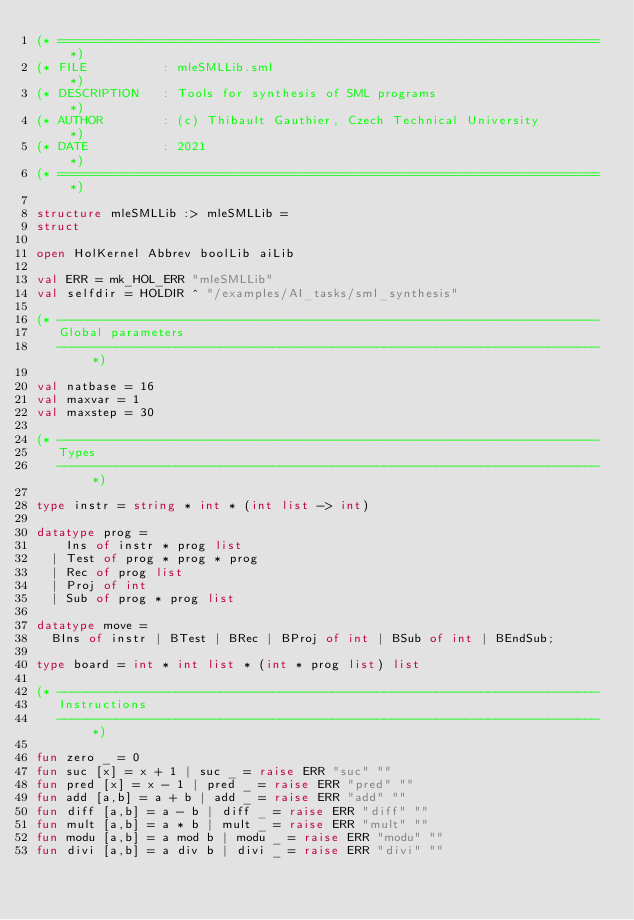Convert code to text. <code><loc_0><loc_0><loc_500><loc_500><_SML_>(* ========================================================================= *)
(* FILE          : mleSMLLib.sml                                             *)
(* DESCRIPTION   : Tools for synthesis of SML programs                       *)
(* AUTHOR        : (c) Thibault Gauthier, Czech Technical University         *)
(* DATE          : 2021                                                      *)
(* ========================================================================= *)

structure mleSMLLib :> mleSMLLib =
struct

open HolKernel Abbrev boolLib aiLib

val ERR = mk_HOL_ERR "mleSMLLib"
val selfdir = HOLDIR ^ "/examples/AI_tasks/sml_synthesis"

(* -------------------------------------------------------------------------
   Global parameters
   ------------------------------------------------------------------------- *)

val natbase = 16
val maxvar = 1
val maxstep = 30

(* -------------------------------------------------------------------------
   Types
   ------------------------------------------------------------------------- *)

type instr = string * int * (int list -> int)

datatype prog =
    Ins of instr * prog list
  | Test of prog * prog * prog
  | Rec of prog list
  | Proj of int
  | Sub of prog * prog list

datatype move =
  BIns of instr | BTest | BRec | BProj of int | BSub of int | BEndSub;

type board = int * int list * (int * prog list) list

(* -------------------------------------------------------------------------
   Instructions
   ------------------------------------------------------------------------- *)

fun zero _ = 0
fun suc [x] = x + 1 | suc _ = raise ERR "suc" ""
fun pred [x] = x - 1 | pred _ = raise ERR "pred" ""
fun add [a,b] = a + b | add _ = raise ERR "add" ""
fun diff [a,b] = a - b | diff _ = raise ERR "diff" ""
fun mult [a,b] = a * b | mult _ = raise ERR "mult" ""
fun modu [a,b] = a mod b | modu _ = raise ERR "modu" ""
fun divi [a,b] = a div b | divi _ = raise ERR "divi" ""
</code> 